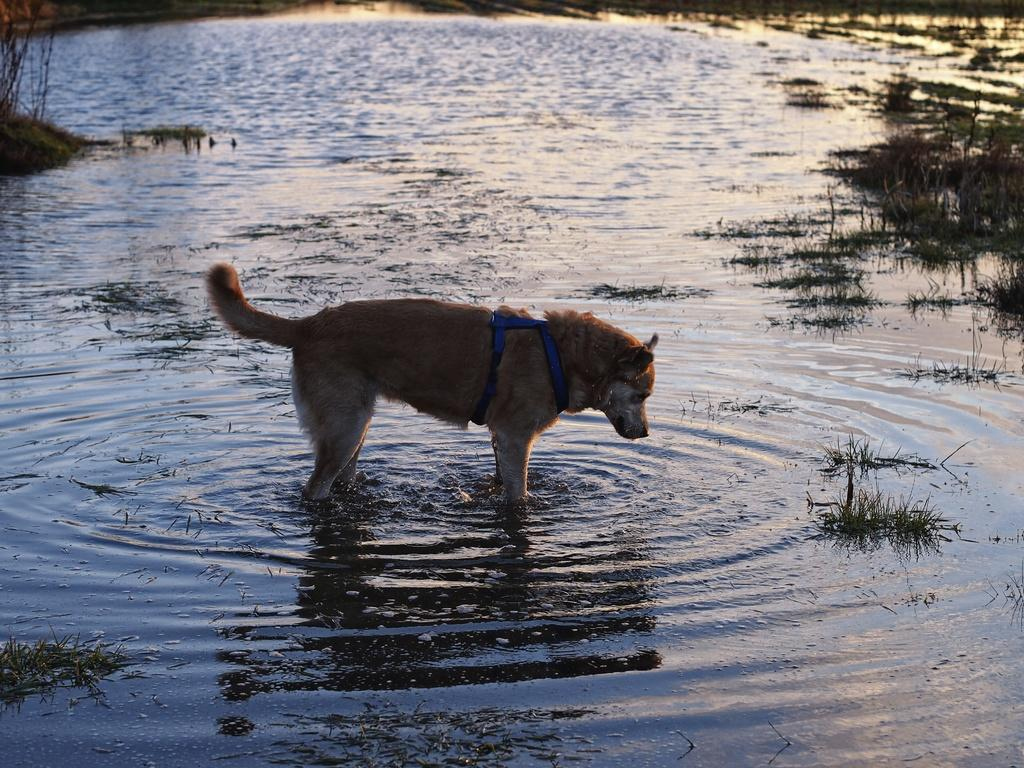What animal is present in the image? There is a dog in the image. Where is the dog located? The dog is standing in the water. What type of vegetation can be seen in the water? There is grass in the water. What type of tree can be seen in the image? There is no tree present in the image. What kind of feast is being prepared in the water? There is no feast being prepared in the image. 